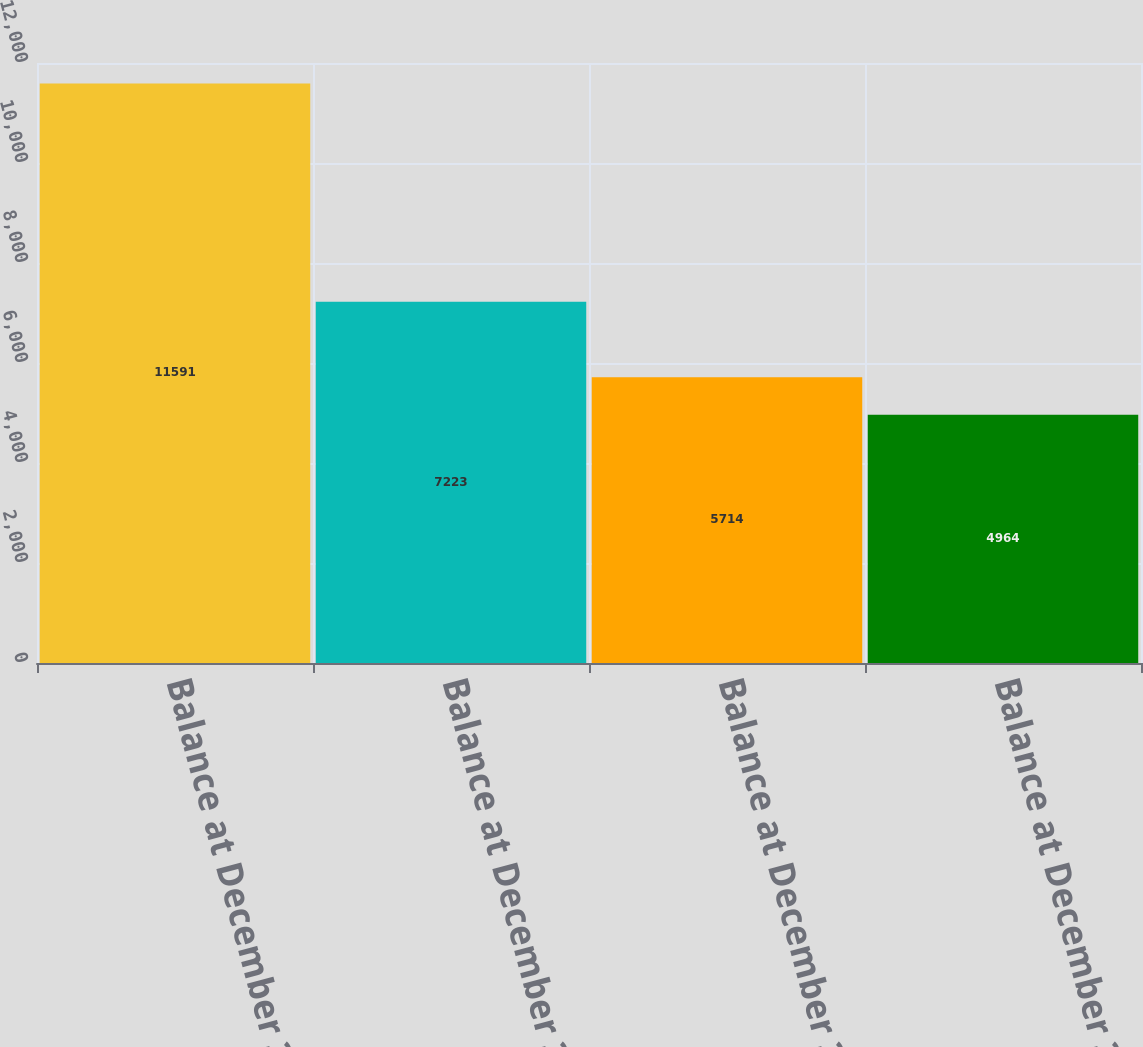Convert chart to OTSL. <chart><loc_0><loc_0><loc_500><loc_500><bar_chart><fcel>Balance at December 31 2015<fcel>Balance at December 31 2016<fcel>Balance at December 31 2017<fcel>Balance at December 31 2018<nl><fcel>11591<fcel>7223<fcel>5714<fcel>4964<nl></chart> 